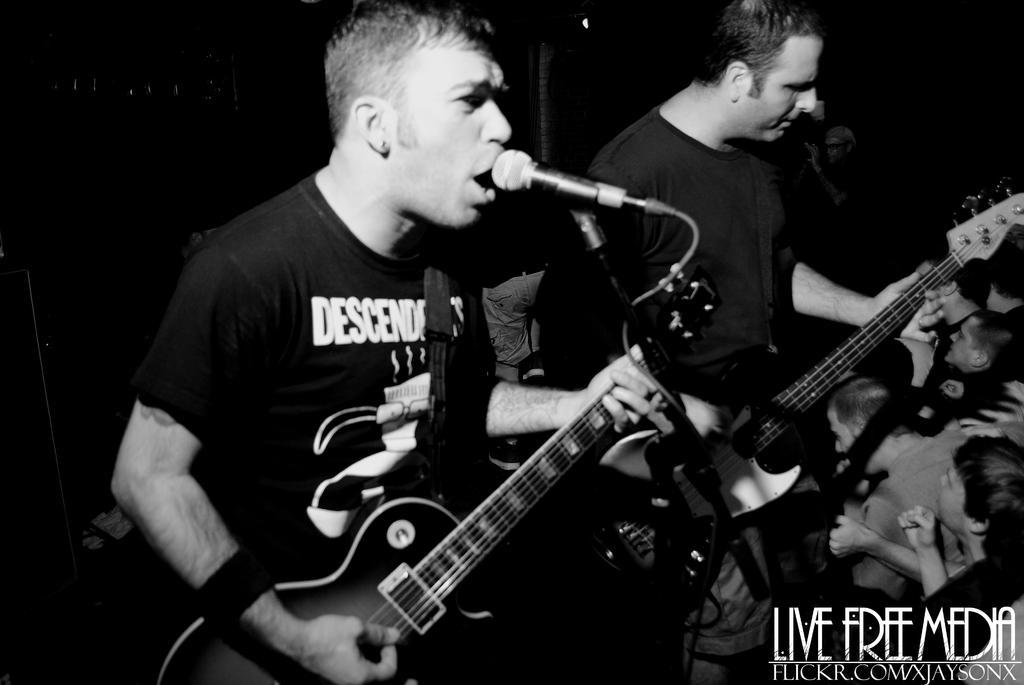Describe this image in one or two sentences. In this image i can see two persons wearing t-shirts standing and holding guitars in their hands, I can see a microphone in front of a person, to the right bottom of the image I can see few people. In the background I can see a light and a person. 